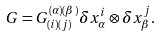<formula> <loc_0><loc_0><loc_500><loc_500>G = G ^ { ( \alpha ) ( \beta ) } _ { ( i ) ( j ) } \delta x ^ { i } _ { \alpha } \otimes \delta x ^ { j } _ { \beta } .</formula> 